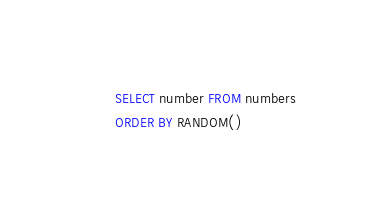<code> <loc_0><loc_0><loc_500><loc_500><_SQL_>SELECT number FROM numbers
ORDER BY RANDOM()</code> 